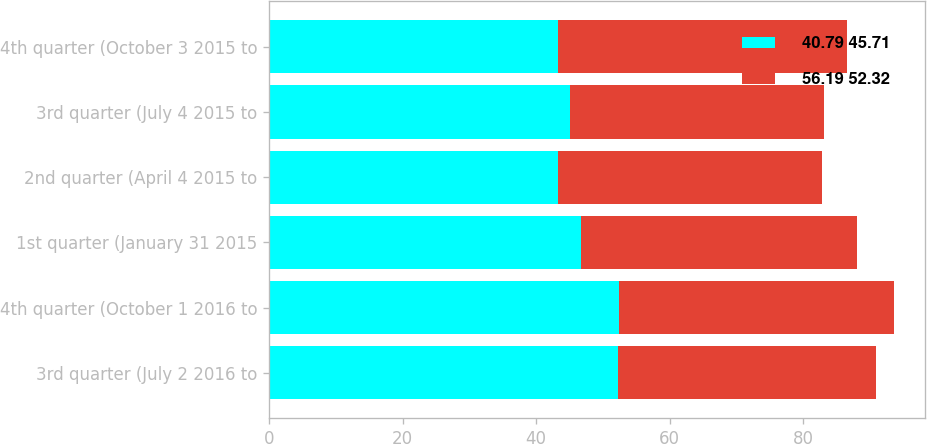Convert chart. <chart><loc_0><loc_0><loc_500><loc_500><stacked_bar_chart><ecel><fcel>3rd quarter (July 2 2016 to<fcel>4th quarter (October 1 2016 to<fcel>1st quarter (January 31 2015<fcel>2nd quarter (April 4 2015 to<fcel>3rd quarter (July 4 2015 to<fcel>4th quarter (October 3 2015 to<nl><fcel>40.79 45.71<fcel>52.33<fcel>52.38<fcel>46.76<fcel>43.2<fcel>45.03<fcel>43.2<nl><fcel>56.19 52.32<fcel>38.5<fcel>41.18<fcel>41.3<fcel>39.63<fcel>38.05<fcel>43.42<nl></chart> 